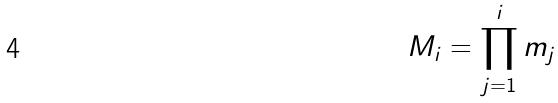Convert formula to latex. <formula><loc_0><loc_0><loc_500><loc_500>M _ { i } = \prod _ { j = 1 } ^ { i } m _ { j }</formula> 